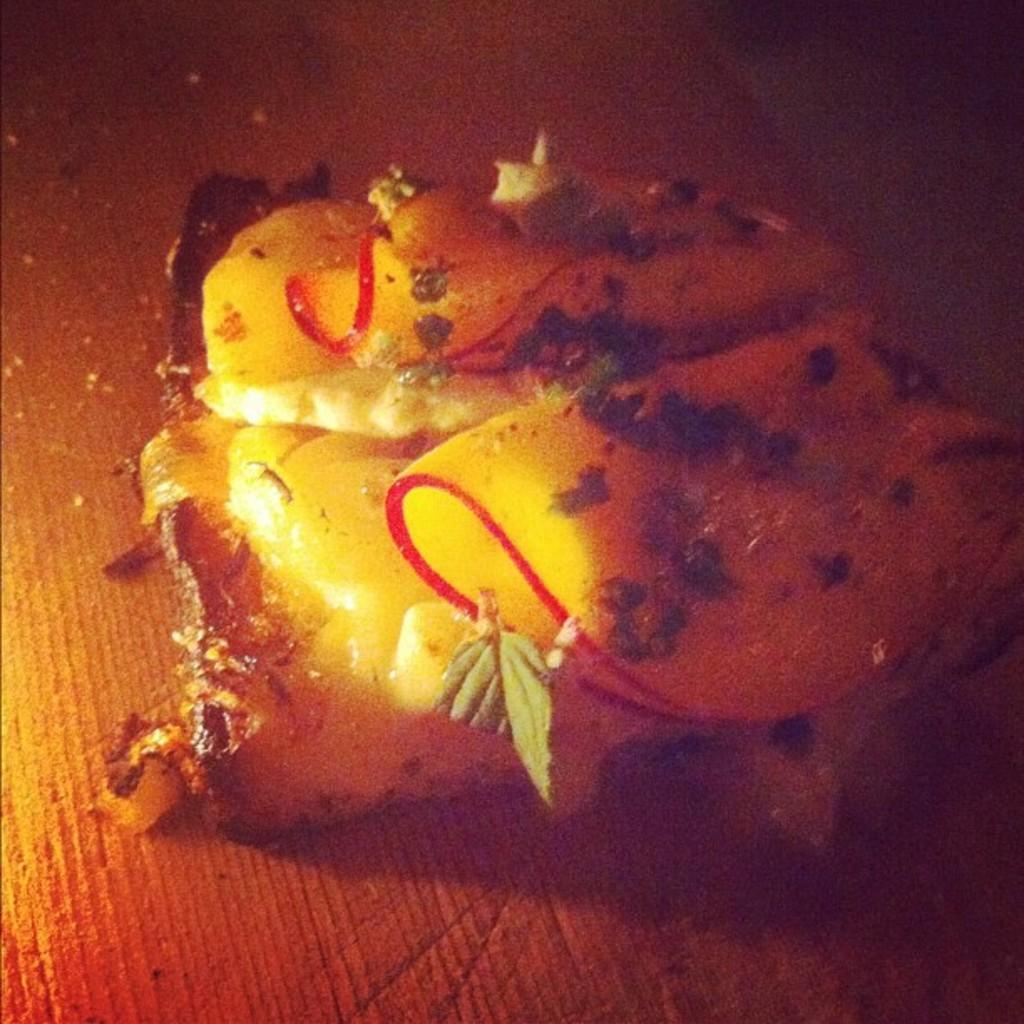Describe this image in one or two sentences. In this picture there is food. At the bottom there is light brown color background. 